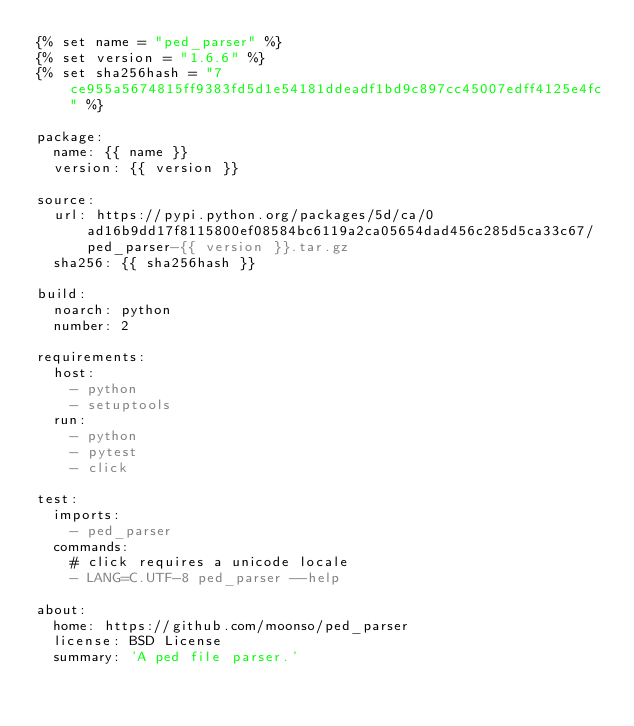<code> <loc_0><loc_0><loc_500><loc_500><_YAML_>{% set name = "ped_parser" %}
{% set version = "1.6.6" %}
{% set sha256hash = "7ce955a5674815ff9383fd5d1e54181ddeadf1bd9c897cc45007edff4125e4fc" %}

package:
  name: {{ name }}
  version: {{ version }}

source:
  url: https://pypi.python.org/packages/5d/ca/0ad16b9dd17f8115800ef08584bc6119a2ca05654dad456c285d5ca33c67/ped_parser-{{ version }}.tar.gz
  sha256: {{ sha256hash }}

build:
  noarch: python
  number: 2

requirements:
  host:
    - python
    - setuptools
  run:
    - python
    - pytest
    - click

test:
  imports:
    - ped_parser
  commands:
    # click requires a unicode locale
    - LANG=C.UTF-8 ped_parser --help

about:
  home: https://github.com/moonso/ped_parser
  license: BSD License
  summary: 'A ped file parser.'
</code> 